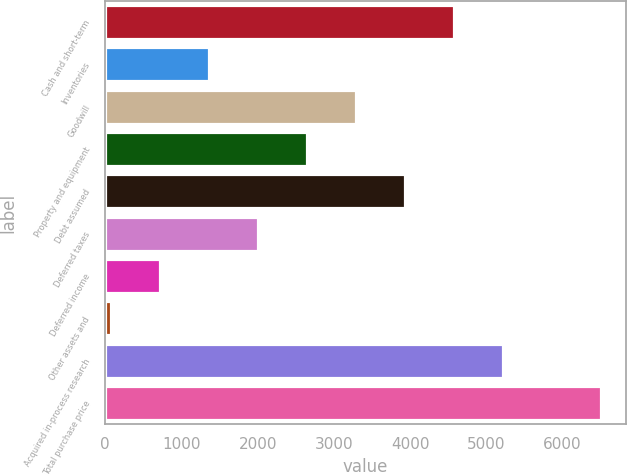Convert chart. <chart><loc_0><loc_0><loc_500><loc_500><bar_chart><fcel>Cash and short-term<fcel>Inventories<fcel>Goodwill<fcel>Property and equipment<fcel>Debt assumed<fcel>Deferred taxes<fcel>Deferred income<fcel>Other assets and<fcel>Acquired in-process research<fcel>Total purchase price<nl><fcel>4576.46<fcel>1359.06<fcel>3289.5<fcel>2646.02<fcel>3932.98<fcel>2002.54<fcel>715.58<fcel>72.1<fcel>5219.94<fcel>6506.9<nl></chart> 